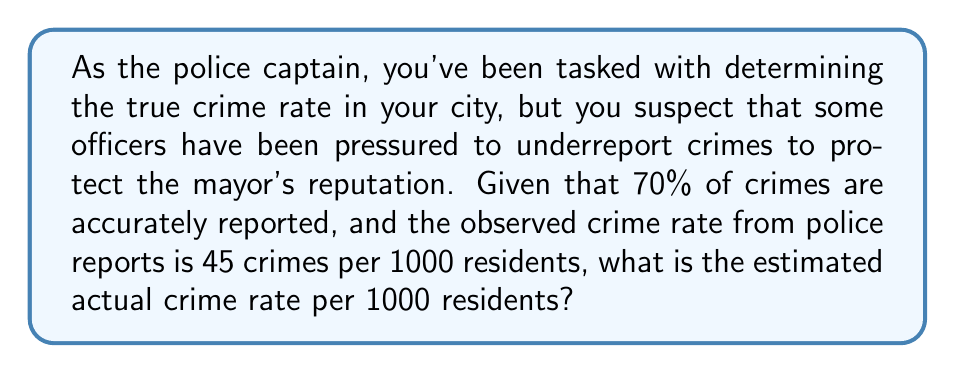What is the answer to this math problem? To solve this inverse problem, we need to work backwards from the observed data to determine the original crime rate. Let's approach this step-by-step:

1) Let $x$ be the actual crime rate per 1000 residents.

2) We know that 70% of crimes are accurately reported. This means that the observed crime rate is 70% of the actual crime rate.

3) We can express this as an equation:
   $0.7x = 45$

4) To solve for $x$, we divide both sides by 0.7:
   $x = \frac{45}{0.7}$

5) Calculating this:
   $x = \frac{45}{0.7} = 64.2857...$

6) Rounding to the nearest whole number (as we're dealing with a rate per 1000 residents), we get 64.

Therefore, the estimated actual crime rate is 64 crimes per 1000 residents.
Answer: 64 crimes per 1000 residents 